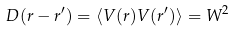Convert formula to latex. <formula><loc_0><loc_0><loc_500><loc_500>D ( { r } - { r } ^ { \prime } ) = \langle V ( { r } ) V ( { r ^ { \prime } } ) \rangle = W ^ { 2 }</formula> 